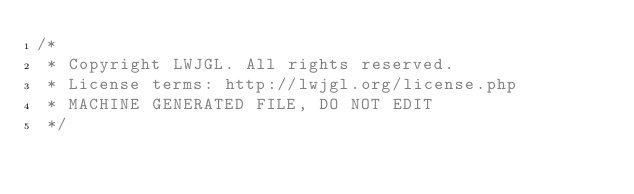Convert code to text. <code><loc_0><loc_0><loc_500><loc_500><_Java_>/*
 * Copyright LWJGL. All rights reserved.
 * License terms: http://lwjgl.org/license.php
 * MACHINE GENERATED FILE, DO NOT EDIT
 */</code> 